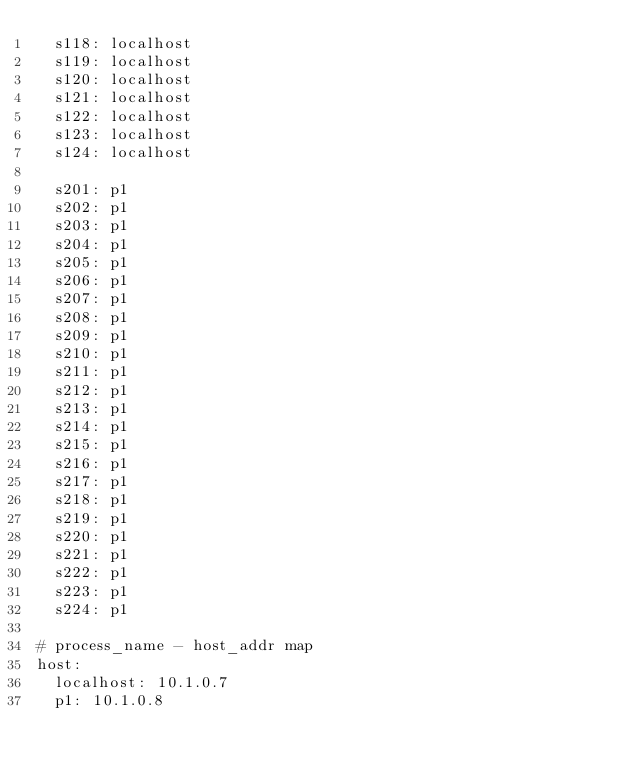<code> <loc_0><loc_0><loc_500><loc_500><_YAML_>  s118: localhost
  s119: localhost
  s120: localhost
  s121: localhost
  s122: localhost
  s123: localhost
  s124: localhost

  s201: p1
  s202: p1
  s203: p1
  s204: p1
  s205: p1
  s206: p1
  s207: p1
  s208: p1
  s209: p1
  s210: p1
  s211: p1
  s212: p1
  s213: p1
  s214: p1
  s215: p1
  s216: p1
  s217: p1
  s218: p1
  s219: p1
  s220: p1
  s221: p1
  s222: p1
  s223: p1
  s224: p1

# process_name - host_addr map
host:
  localhost: 10.1.0.7 
  p1: 10.1.0.8
</code> 